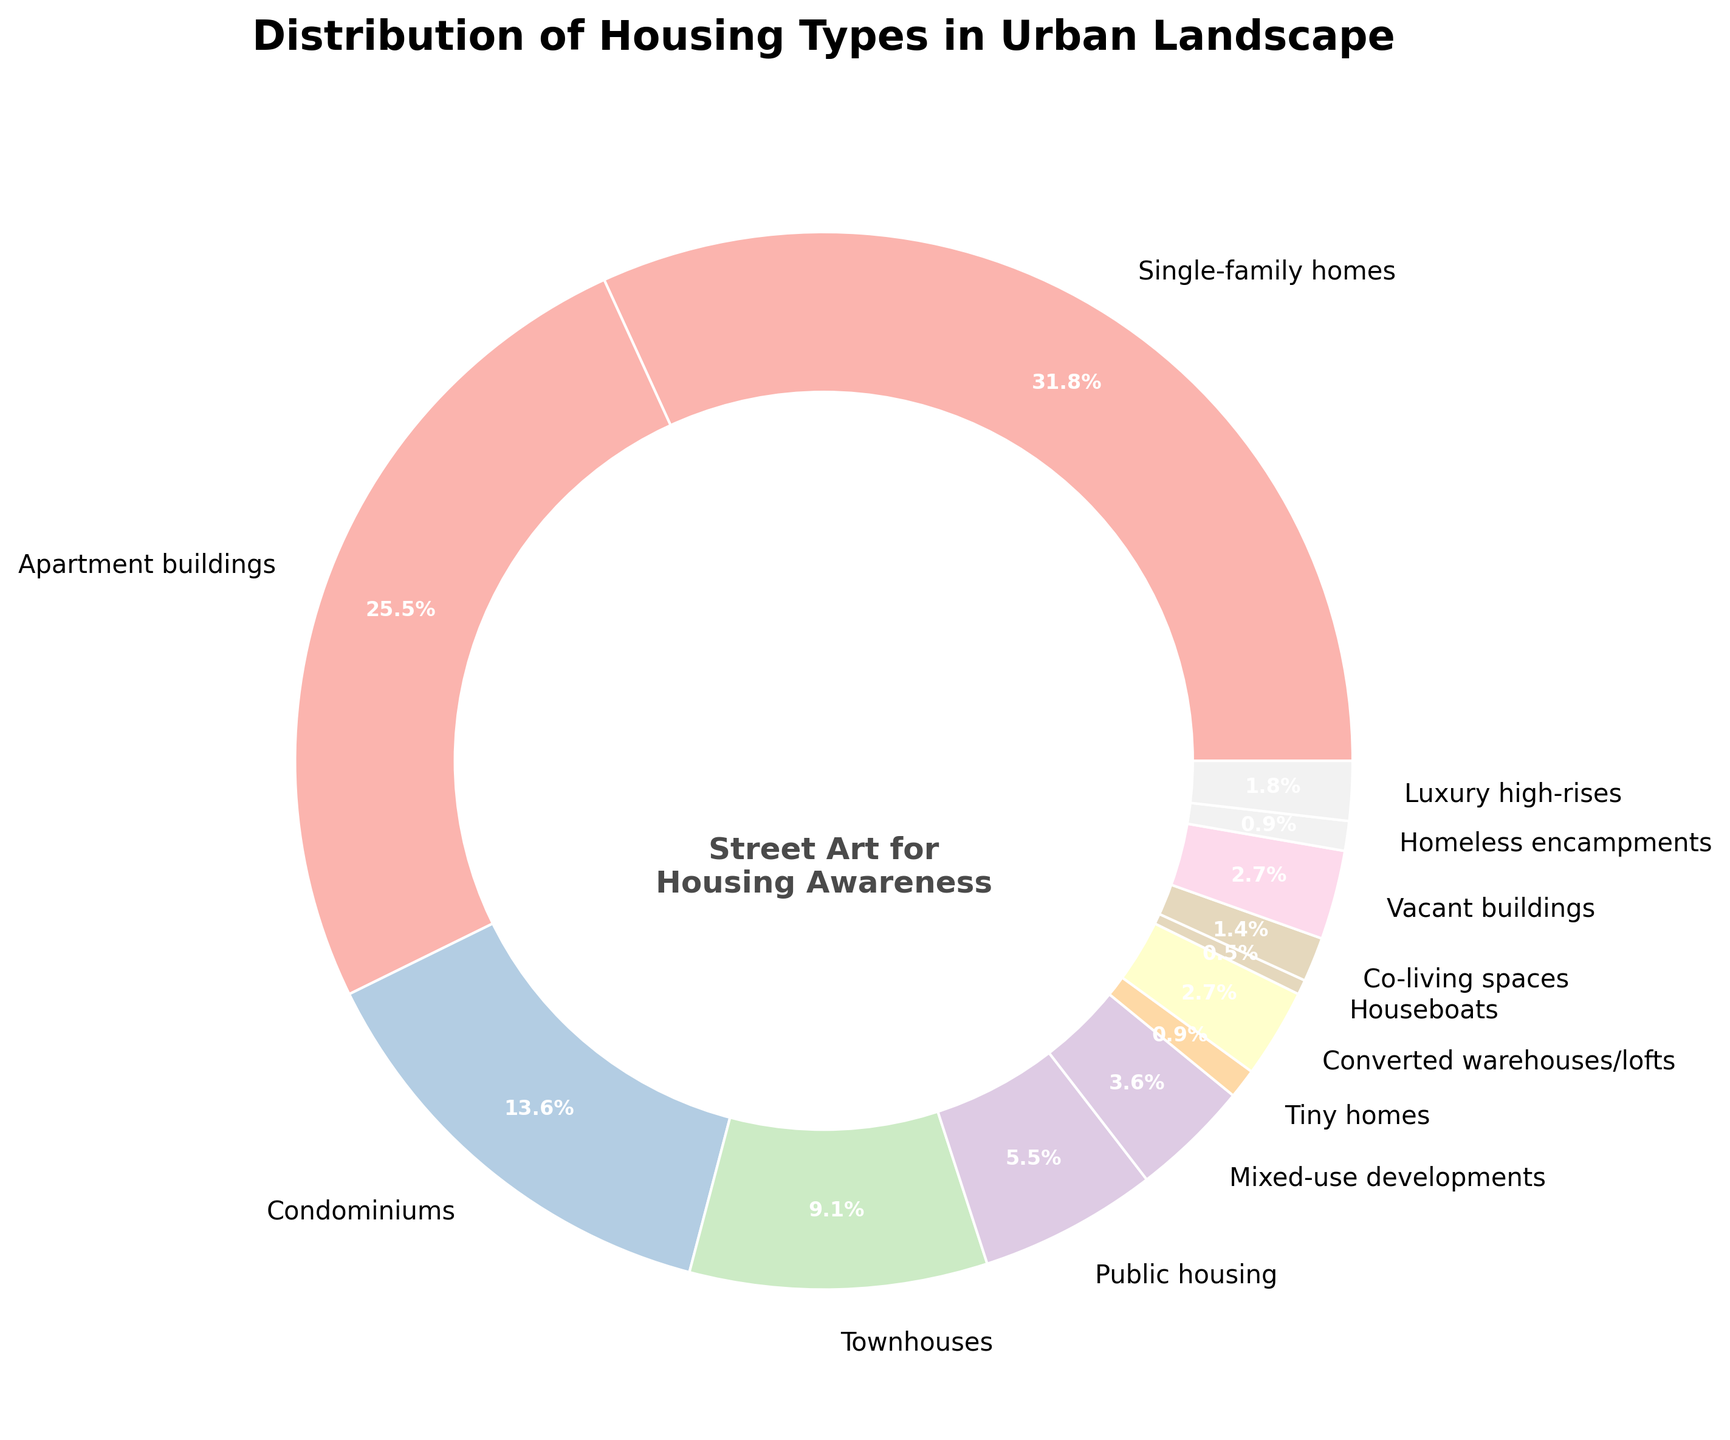What percentage of the urban housing types are condominiums? To find this, simply refer to the pie chart to see the percentage value associated with condominiums.
Answer: 15% Which housing type takes up a larger percentage: Townhouses or Converted warehouses/lofts? Look for the percentage values of townhouses and converted warehouses/lofts and compare them. Townhouses have 10% while Converted warehouses/lofts have 3%.
Answer: Townhouses What is the combined percentage of Single-family homes, Apartment buildings, and Condominiums? Sum the percentages for these three housing types: 35% (Single-family homes) + 28% (Apartment buildings) + 15% (Condominiums) = 78%.
Answer: 78% Identify the housing type with the smallest representation in the urban landscape. Examine the pie chart and find the segment with the smallest percentage. Houseboats have the smallest segment at 0.5%.
Answer: Houseboats How much more significant is the percentage of Single-family homes compared to Public housing? Subtract the percentage of Public housing (6%) from that of Single-family homes (35%): 35% - 6% = 29%.
Answer: 29% What is the median percentage value of all housing types in the urban landscape? Arrange the percentages in ascending order: 0.5, 1, 1.5, 3, 3, 4, 6, 10, 15, 28, 35. The median value is the middle one, which is 6%, since it is the 6th value in a list of 11.
Answer: 6% Does the chart indicate more Tiny homes or Co-living spaces? Compare the percentages for Tiny homes (1%) and Co-living spaces (1.5%). Co-living spaces have a higher percentage.
Answer: Co-living spaces What is the total percentage of housing types that contribute less than 5% each to the urban landscape? Sum the percentages for all housing types below 5%: Houseboats (0.5%) + Tiny homes (1%) + Co-living spaces (1.5%) + Mixed-use developments (4%) + Converted warehouses/lofts (3%) + Luxury high-rises (2%) + Vacant buildings (3%) + Homeless encampments (1%) = 16%.
Answer: 16% Which housing type is represented by the second-largest segment? From the chart, the second-largest segment (after Single-family homes) is Apartment buildings at 28%.
Answer: Apartment buildings How does the percentage of Mixed-use developments compare to that of Tiny homes and Co-living spaces combined? Mixed-use developments have 4%. Tiny homes (1%) and Co-living spaces (1.5%) combined make up 2.5%. 4% is greater than 2.5%.
Answer: Greater 